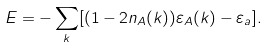Convert formula to latex. <formula><loc_0><loc_0><loc_500><loc_500>E = - \sum _ { k } [ ( 1 - 2 n _ { A } ( { k } ) ) \varepsilon _ { A } ( { k } ) - \varepsilon _ { a } ] .</formula> 